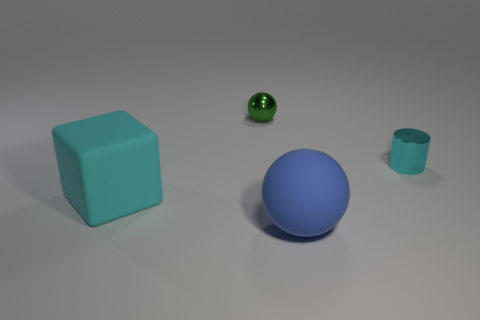How many blocks are big cyan rubber things or small cyan metal objects? 1 